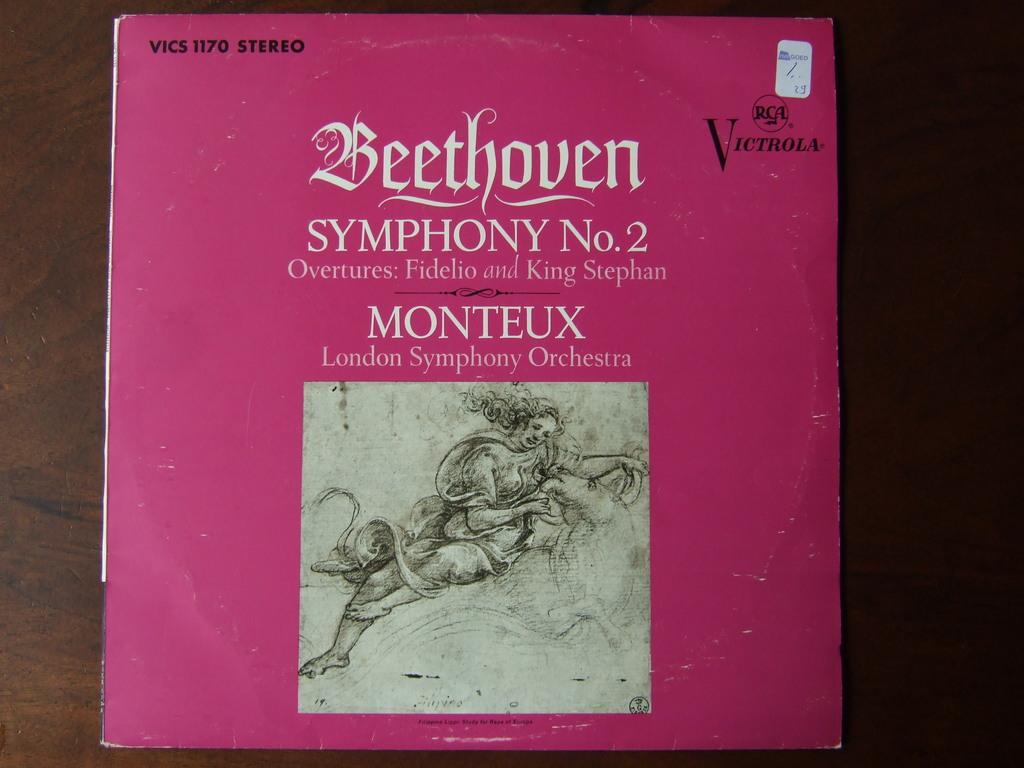Which beethoven symphony is this?
Give a very brief answer. No. 2. 